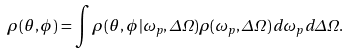Convert formula to latex. <formula><loc_0><loc_0><loc_500><loc_500>\rho ( \theta , \phi ) = \int \rho ( \theta , \phi | \omega _ { p } , \Delta \Omega ) \rho ( \omega _ { p } , \Delta \Omega ) \, d \omega _ { p } \, d \Delta \Omega .</formula> 